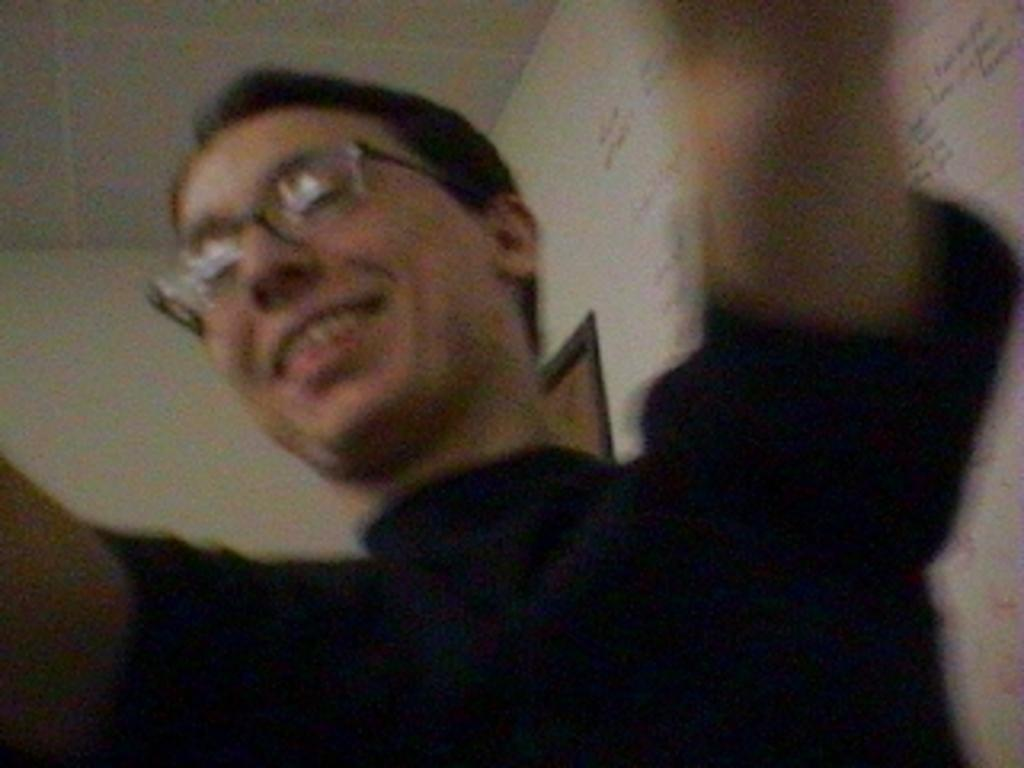What is the main subject of the image? There is a person in the image. What is the person wearing? The person is wearing a black shirt. What is the person's facial expression? The person is smiling. What can be seen behind the person? There is a wall behind the person. What type of bread can be seen in the person's hand in the image? There is no bread present in the image; the person is not holding anything. 